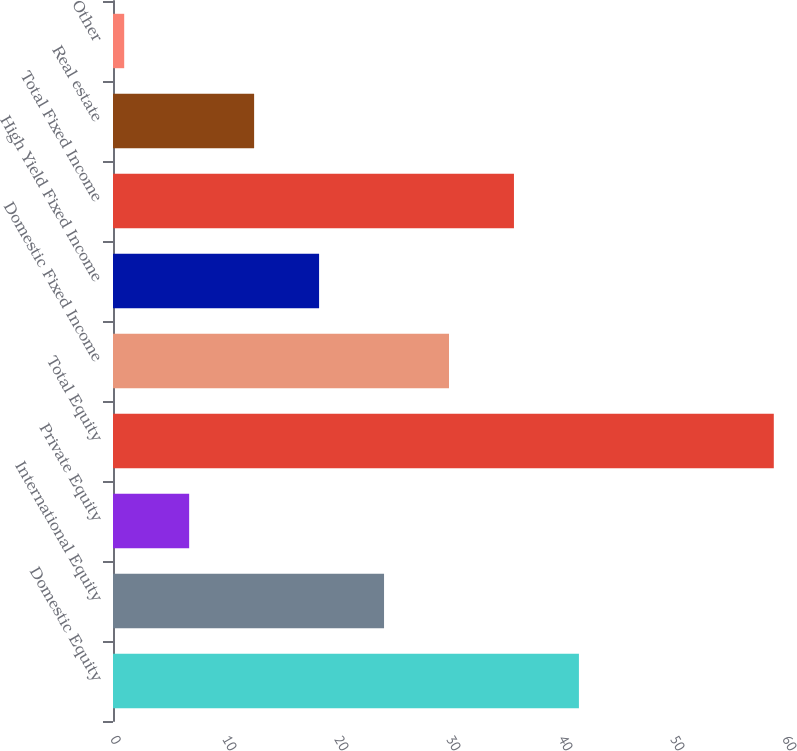<chart> <loc_0><loc_0><loc_500><loc_500><bar_chart><fcel>Domestic Equity<fcel>International Equity<fcel>Private Equity<fcel>Total Equity<fcel>Domestic Fixed Income<fcel>High Yield Fixed Income<fcel>Total Fixed Income<fcel>Real estate<fcel>Other<nl><fcel>41.6<fcel>24.2<fcel>6.8<fcel>59<fcel>30<fcel>18.4<fcel>35.8<fcel>12.6<fcel>1<nl></chart> 